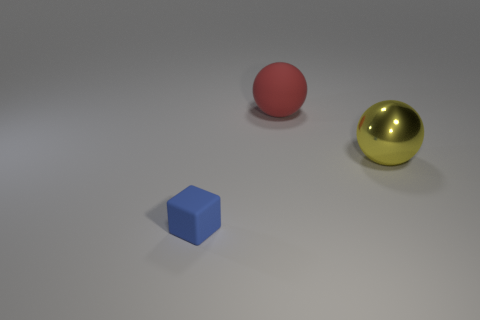Add 2 rubber cubes. How many objects exist? 5 Subtract all red spheres. How many spheres are left? 1 Subtract all blue blocks. Subtract all small blue blocks. How many objects are left? 1 Add 2 large yellow metal spheres. How many large yellow metal spheres are left? 3 Add 1 purple matte cylinders. How many purple matte cylinders exist? 1 Subtract 0 cyan cylinders. How many objects are left? 3 Subtract all blocks. How many objects are left? 2 Subtract 1 cubes. How many cubes are left? 0 Subtract all yellow spheres. Subtract all red cylinders. How many spheres are left? 1 